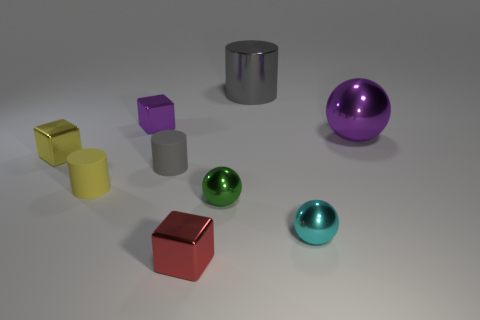Add 1 large spheres. How many objects exist? 10 Subtract all spheres. How many objects are left? 6 Add 6 tiny purple objects. How many tiny purple objects exist? 7 Subtract 0 gray spheres. How many objects are left? 9 Subtract all tiny yellow objects. Subtract all gray things. How many objects are left? 5 Add 3 metallic objects. How many metallic objects are left? 10 